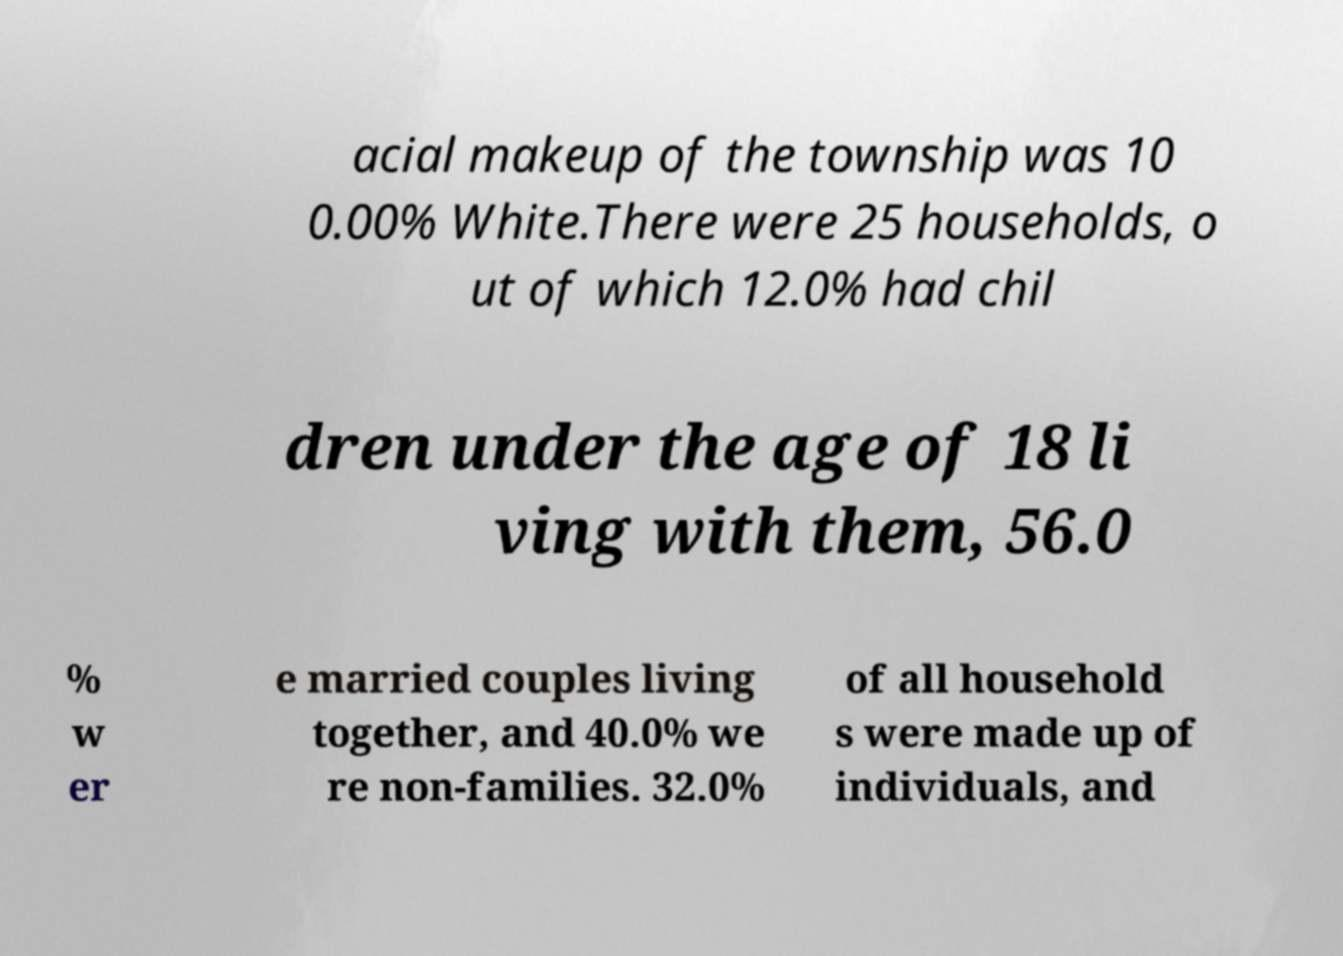What messages or text are displayed in this image? I need them in a readable, typed format. acial makeup of the township was 10 0.00% White.There were 25 households, o ut of which 12.0% had chil dren under the age of 18 li ving with them, 56.0 % w er e married couples living together, and 40.0% we re non-families. 32.0% of all household s were made up of individuals, and 